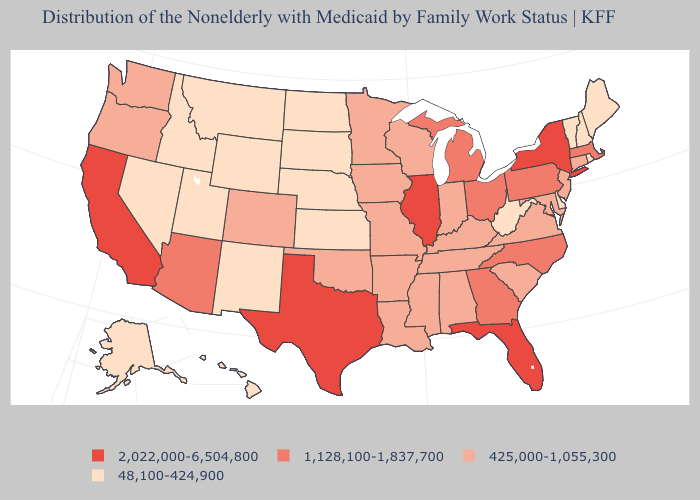Among the states that border Maine , which have the highest value?
Answer briefly. New Hampshire. Does North Carolina have the lowest value in the South?
Concise answer only. No. Name the states that have a value in the range 1,128,100-1,837,700?
Be succinct. Arizona, Georgia, Massachusetts, Michigan, North Carolina, Ohio, Pennsylvania. What is the value of West Virginia?
Concise answer only. 48,100-424,900. What is the value of North Carolina?
Keep it brief. 1,128,100-1,837,700. Name the states that have a value in the range 425,000-1,055,300?
Write a very short answer. Alabama, Arkansas, Colorado, Connecticut, Indiana, Iowa, Kentucky, Louisiana, Maryland, Minnesota, Mississippi, Missouri, New Jersey, Oklahoma, Oregon, South Carolina, Tennessee, Virginia, Washington, Wisconsin. What is the value of Mississippi?
Short answer required. 425,000-1,055,300. Does Texas have the highest value in the USA?
Quick response, please. Yes. What is the lowest value in the USA?
Give a very brief answer. 48,100-424,900. What is the lowest value in states that border Colorado?
Write a very short answer. 48,100-424,900. Which states hav the highest value in the West?
Keep it brief. California. What is the value of New Hampshire?
Concise answer only. 48,100-424,900. What is the value of Louisiana?
Concise answer only. 425,000-1,055,300. What is the value of Iowa?
Write a very short answer. 425,000-1,055,300. Which states have the lowest value in the Northeast?
Concise answer only. Maine, New Hampshire, Rhode Island, Vermont. 